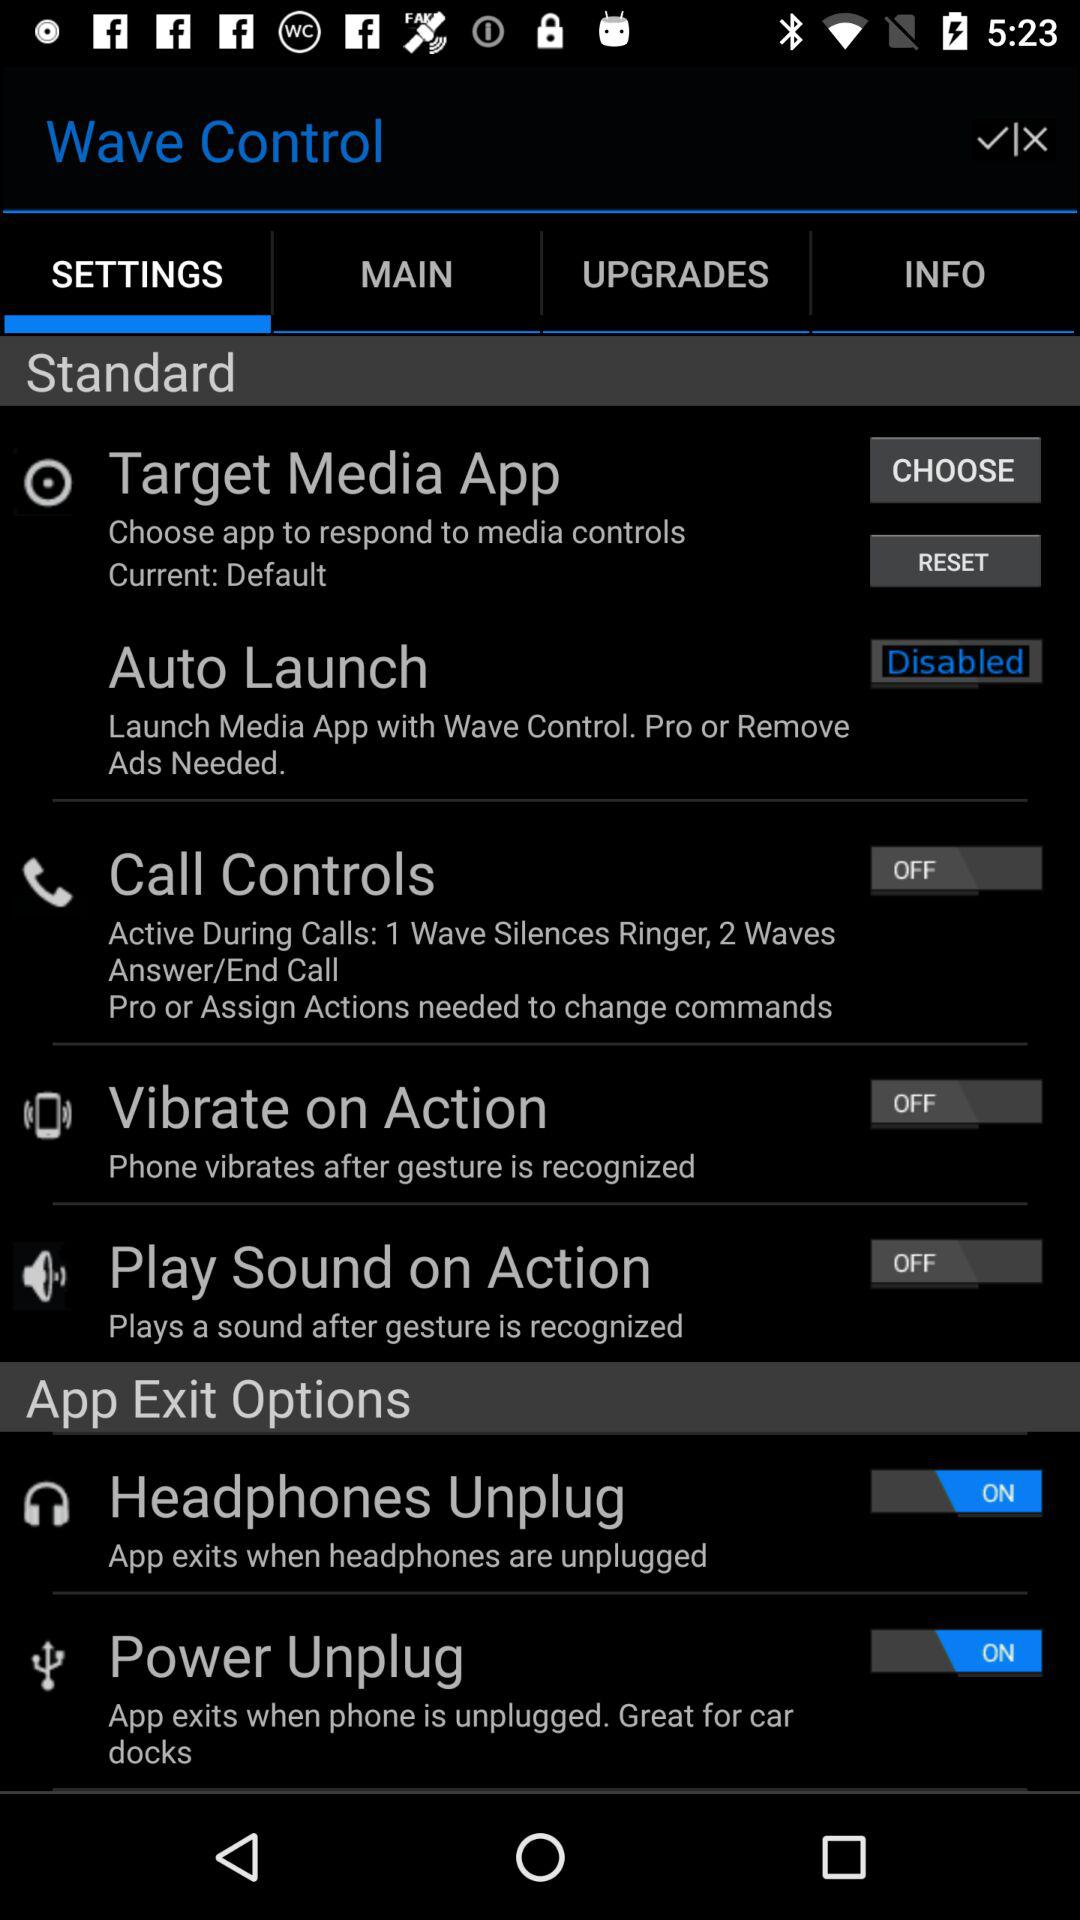Which settings would you recommend activating for the best user experience? For an enhanced user experience, activating 'Auto Launch' might be convenient to have the media app ready as soon as a specific event occurs. Additionally, enabling 'Call Controls' may help manage calls without having to touch the device. Preferences can vary, so it's best to customize these settings based on individual needs. 